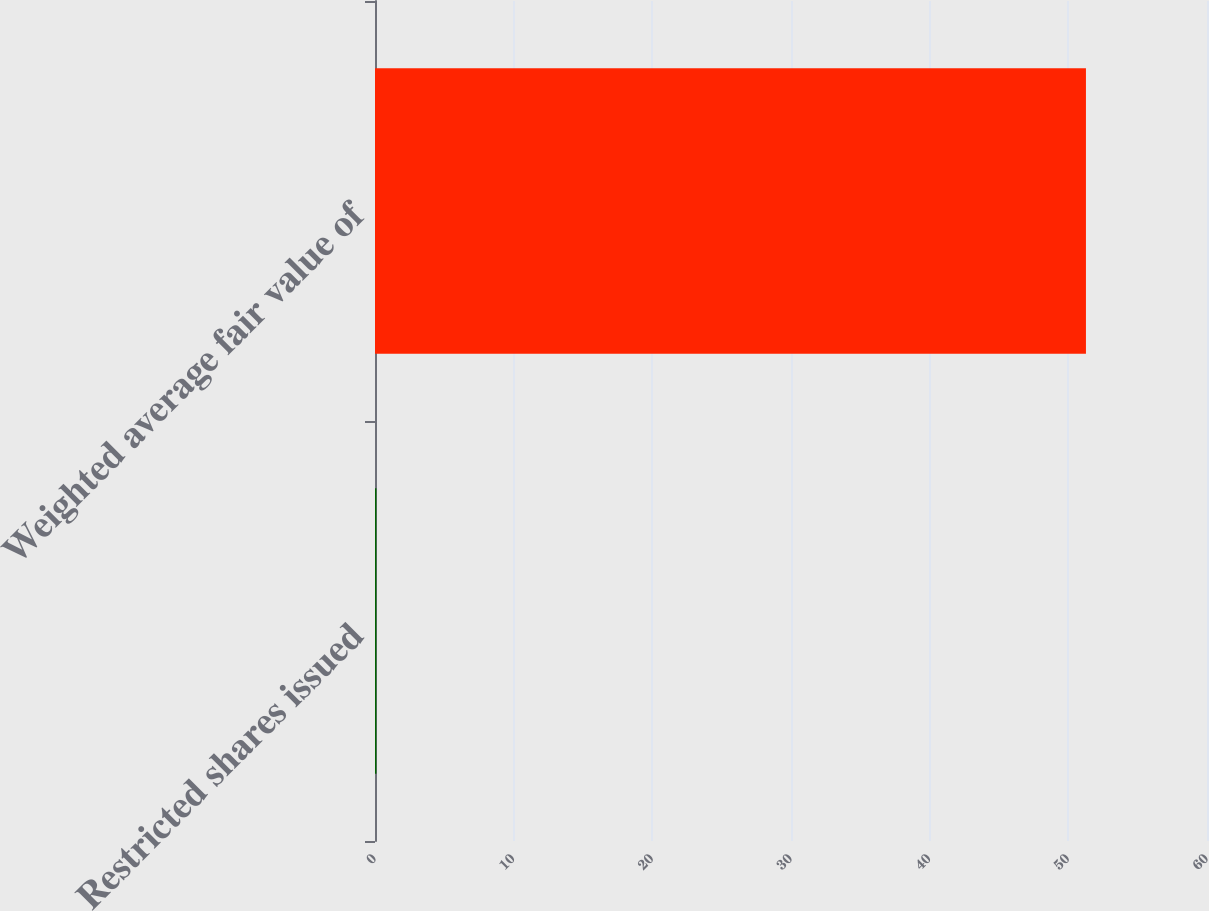<chart> <loc_0><loc_0><loc_500><loc_500><bar_chart><fcel>Restricted shares issued<fcel>Weighted average fair value of<nl><fcel>0.1<fcel>51.27<nl></chart> 